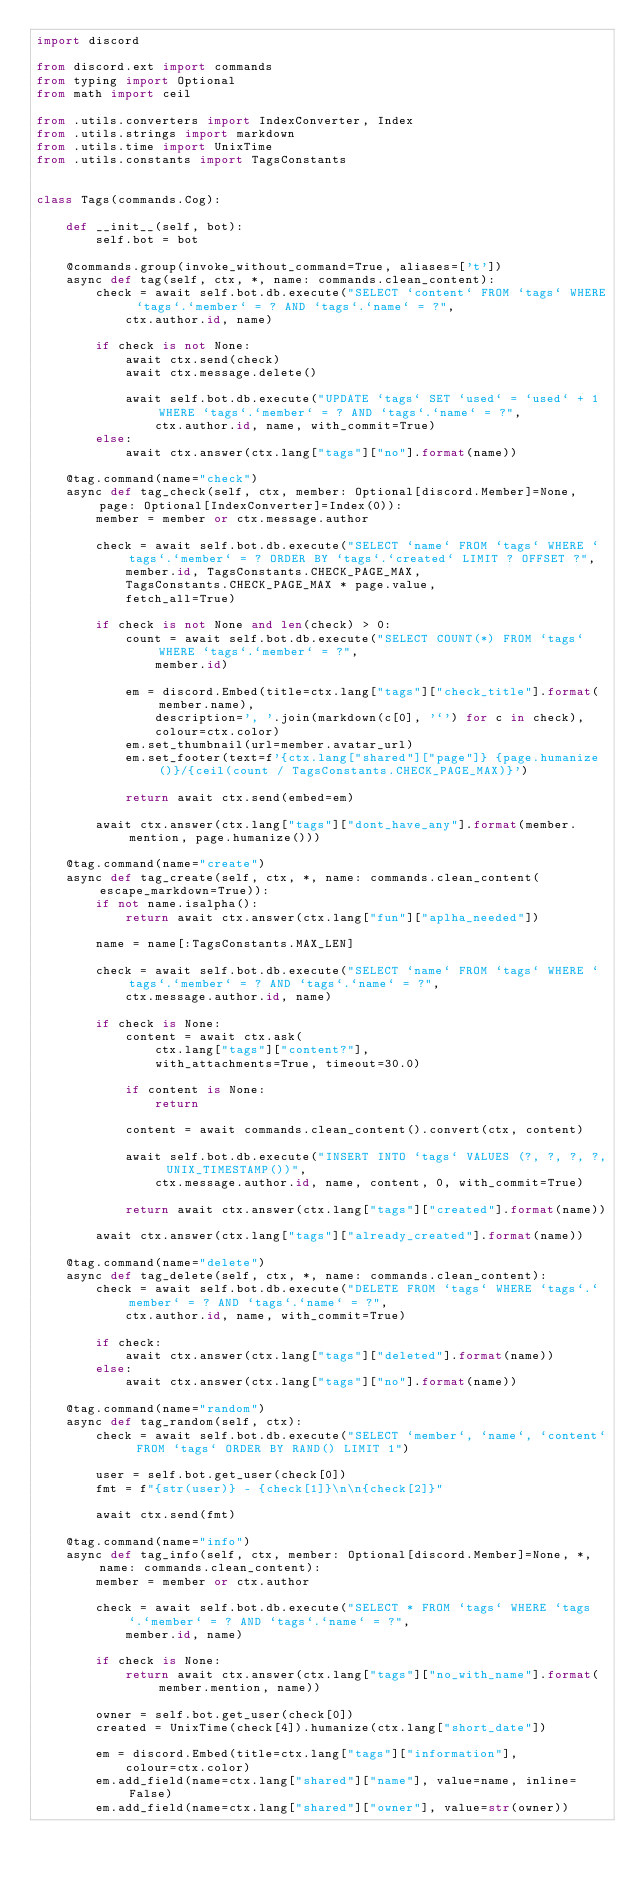<code> <loc_0><loc_0><loc_500><loc_500><_Python_>import discord

from discord.ext import commands
from typing import Optional
from math import ceil

from .utils.converters import IndexConverter, Index
from .utils.strings import markdown
from .utils.time import UnixTime
from .utils.constants import TagsConstants


class Tags(commands.Cog):

    def __init__(self, bot):
        self.bot = bot

    @commands.group(invoke_without_command=True, aliases=['t'])
    async def tag(self, ctx, *, name: commands.clean_content):
        check = await self.bot.db.execute("SELECT `content` FROM `tags` WHERE `tags`.`member` = ? AND `tags`.`name` = ?",
            ctx.author.id, name)

        if check is not None:
            await ctx.send(check)
            await ctx.message.delete()

            await self.bot.db.execute("UPDATE `tags` SET `used` = `used` + 1 WHERE `tags`.`member` = ? AND `tags`.`name` = ?",
                ctx.author.id, name, with_commit=True)
        else:
            await ctx.answer(ctx.lang["tags"]["no"].format(name))

    @tag.command(name="check")
    async def tag_check(self, ctx, member: Optional[discord.Member]=None, page: Optional[IndexConverter]=Index(0)):
        member = member or ctx.message.author
    
        check = await self.bot.db.execute("SELECT `name` FROM `tags` WHERE `tags`.`member` = ? ORDER BY `tags`.`created` LIMIT ? OFFSET ?",
            member.id, TagsConstants.CHECK_PAGE_MAX, 
            TagsConstants.CHECK_PAGE_MAX * page.value,
            fetch_all=True)

        if check is not None and len(check) > 0:
            count = await self.bot.db.execute("SELECT COUNT(*) FROM `tags` WHERE `tags`.`member` = ?",
                member.id)

            em = discord.Embed(title=ctx.lang["tags"]["check_title"].format(member.name),
                description=', '.join(markdown(c[0], '`') for c in check),
                colour=ctx.color)
            em.set_thumbnail(url=member.avatar_url)
            em.set_footer(text=f'{ctx.lang["shared"]["page"]} {page.humanize()}/{ceil(count / TagsConstants.CHECK_PAGE_MAX)}')           

            return await ctx.send(embed=em)

        await ctx.answer(ctx.lang["tags"]["dont_have_any"].format(member.mention, page.humanize()))            

    @tag.command(name="create")
    async def tag_create(self, ctx, *, name: commands.clean_content(escape_markdown=True)):
        if not name.isalpha():
            return await ctx.answer(ctx.lang["fun"]["aplha_needed"])
        
        name = name[:TagsConstants.MAX_LEN]

        check = await self.bot.db.execute("SELECT `name` FROM `tags` WHERE `tags`.`member` = ? AND `tags`.`name` = ?",
            ctx.message.author.id, name)

        if check is None:
            content = await ctx.ask(
                ctx.lang["tags"]["content?"],
                with_attachments=True, timeout=30.0)

            if content is None:
                return

            content = await commands.clean_content().convert(ctx, content)

            await self.bot.db.execute("INSERT INTO `tags` VALUES (?, ?, ?, ?, UNIX_TIMESTAMP())",
                ctx.message.author.id, name, content, 0, with_commit=True)

            return await ctx.answer(ctx.lang["tags"]["created"].format(name))

        await ctx.answer(ctx.lang["tags"]["already_created"].format(name))
            
    @tag.command(name="delete")
    async def tag_delete(self, ctx, *, name: commands.clean_content):
        check = await self.bot.db.execute("DELETE FROM `tags` WHERE `tags`.`member` = ? AND `tags`.`name` = ?",
            ctx.author.id, name, with_commit=True)

        if check:
            await ctx.answer(ctx.lang["tags"]["deleted"].format(name))
        else:
            await ctx.answer(ctx.lang["tags"]["no"].format(name))

    @tag.command(name="random")
    async def tag_random(self, ctx):
        check = await self.bot.db.execute("SELECT `member`, `name`, `content` FROM `tags` ORDER BY RAND() LIMIT 1")

        user = self.bot.get_user(check[0])
        fmt = f"{str(user)} - {check[1]}\n\n{check[2]}"

        await ctx.send(fmt)

    @tag.command(name="info")
    async def tag_info(self, ctx, member: Optional[discord.Member]=None, *, name: commands.clean_content):
        member = member or ctx.author

        check = await self.bot.db.execute("SELECT * FROM `tags` WHERE `tags`.`member` = ? AND `tags`.`name` = ?",
            member.id, name)

        if check is None:
            return await ctx.answer(ctx.lang["tags"]["no_with_name"].format(member.mention, name))

        owner = self.bot.get_user(check[0])
        created = UnixTime(check[4]).humanize(ctx.lang["short_date"])

        em = discord.Embed(title=ctx.lang["tags"]["information"], 
            colour=ctx.color)
        em.add_field(name=ctx.lang["shared"]["name"], value=name, inline=False)
        em.add_field(name=ctx.lang["shared"]["owner"], value=str(owner))</code> 